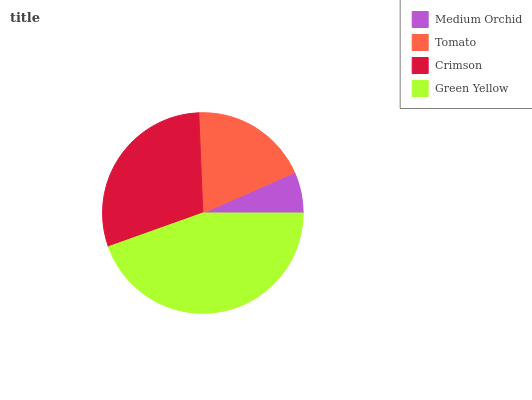Is Medium Orchid the minimum?
Answer yes or no. Yes. Is Green Yellow the maximum?
Answer yes or no. Yes. Is Tomato the minimum?
Answer yes or no. No. Is Tomato the maximum?
Answer yes or no. No. Is Tomato greater than Medium Orchid?
Answer yes or no. Yes. Is Medium Orchid less than Tomato?
Answer yes or no. Yes. Is Medium Orchid greater than Tomato?
Answer yes or no. No. Is Tomato less than Medium Orchid?
Answer yes or no. No. Is Crimson the high median?
Answer yes or no. Yes. Is Tomato the low median?
Answer yes or no. Yes. Is Green Yellow the high median?
Answer yes or no. No. Is Medium Orchid the low median?
Answer yes or no. No. 